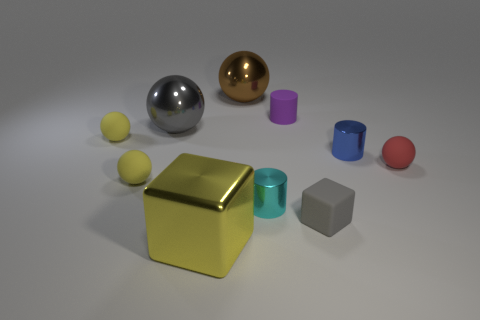There is a large thing that is the same color as the tiny matte cube; what is it made of? metal 